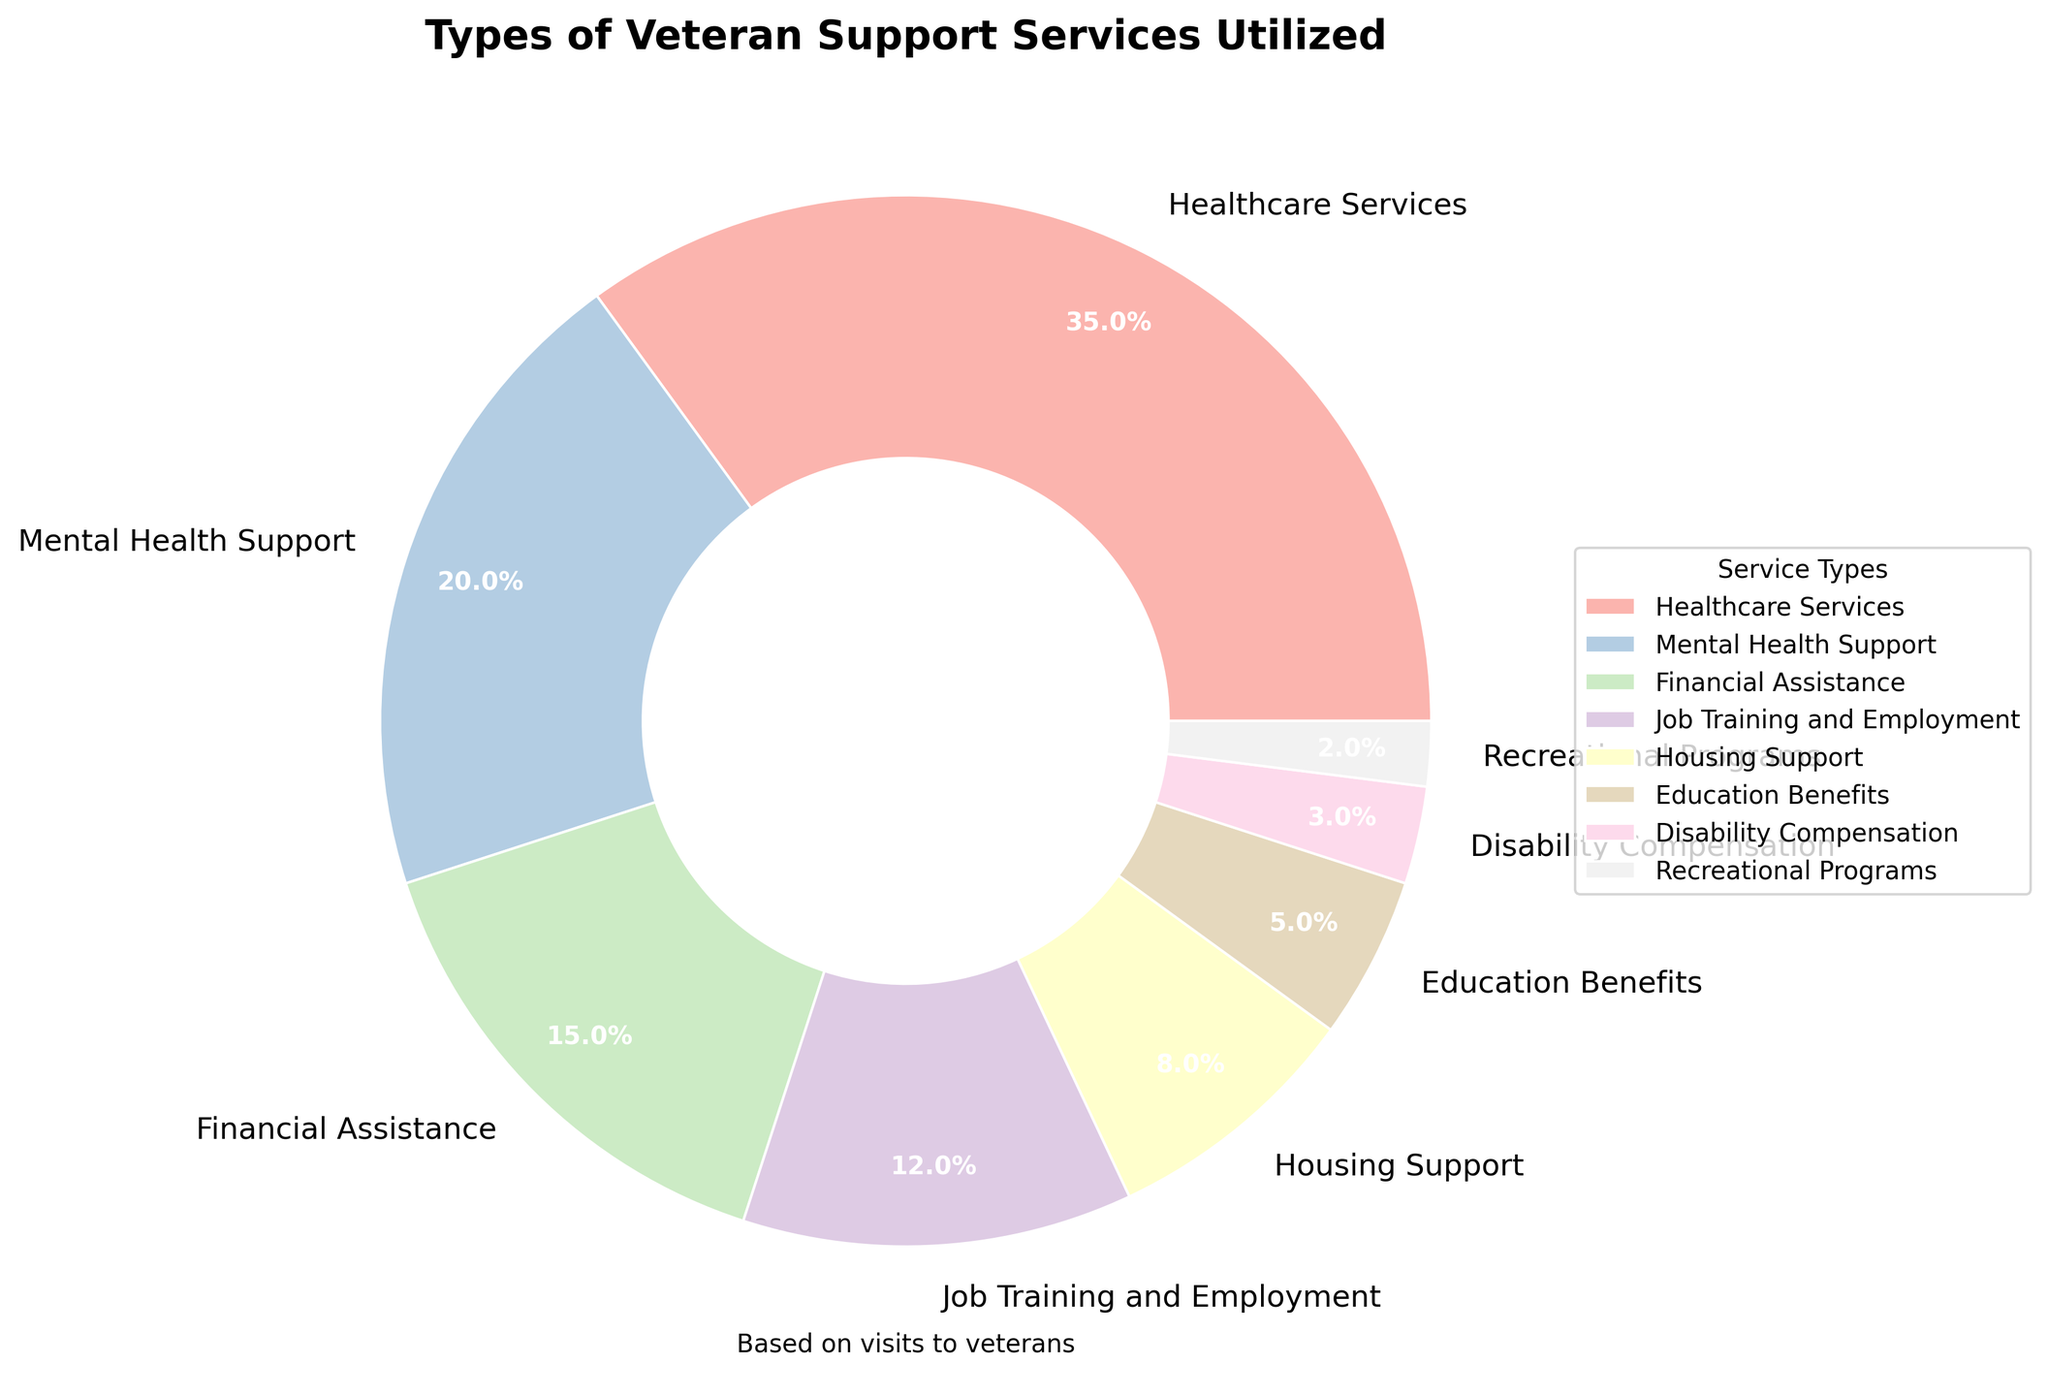What percentage of veterans utilized Healthcare Services? According to the pie chart, Healthcare Services have the largest wedge marked 35%.
Answer: 35% Which service has the least utilization by veterans? The smallest wedge in the pie chart represents Recreational Programs at 2%.
Answer: Recreational Programs How much more popular are Healthcare Services compared to Education Benefits? Healthcare Services have a percentage of 35%, and Education Benefits have 5%. The difference is 35% - 5% = 30%.
Answer: 30% If you add up the percentages for Healthcare Services, Mental Health Support, and Financial Assistance, what is the total? Healthcare Services is 35%, Mental Health Support is 20%, and Financial Assistance is 15%. Summing these gives 35% + 20% + 15% = 70%.
Answer: 70% Are Financial Assistance and Housing Support together more than Job Training and Employment? Financial Assistance is 15% and Housing Support is 8%, together they add up to 15% + 8% = 23%. Job Training and Employment is 12%, and 23% is more than 12%.
Answer: Yes Which category uses more services: Disability Compensation or Recreational Programs? The wedge for Disability Compensation is 3%, while Recreational Programs is 2%, so Disability Compensation is more.
Answer: Disability Compensation Calculate the average percentage for Financial Assistance, Job Training and Employment, Housing Support, and Education Benefits. The percentages are 15%, 12%, 8%, and 5%. Summing them gives 40%, then dividing by 4 (the number of services) gives 40% / 4 = 10%.
Answer: 10% How much lower is the percentage for Mental Health Support compared to Healthcare Services? Mental Health Support is 20% and Healthcare Services is 35%. The difference is 35% - 20% = 15%.
Answer: 15% If you combine all services except Healthcare Services, what percentage of veterans utilized these other services? All other services sum to 100% - 35% (Healthcare Services) = 65%.
Answer: 65% Which two service types are closest in utilization percentages? The pie chart shows that Housing Support is at 8% and Education Benefits are at 5%, which are closest in percentages.
Answer: Housing Support and Education Benefits 